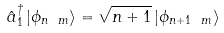Convert formula to latex. <formula><loc_0><loc_0><loc_500><loc_500>\hat { a } ^ { \dagger } _ { 1 } \left | \phi _ { n \ m } \right > = \sqrt { n + 1 } \left | \phi _ { n + 1 \ m } \right ></formula> 